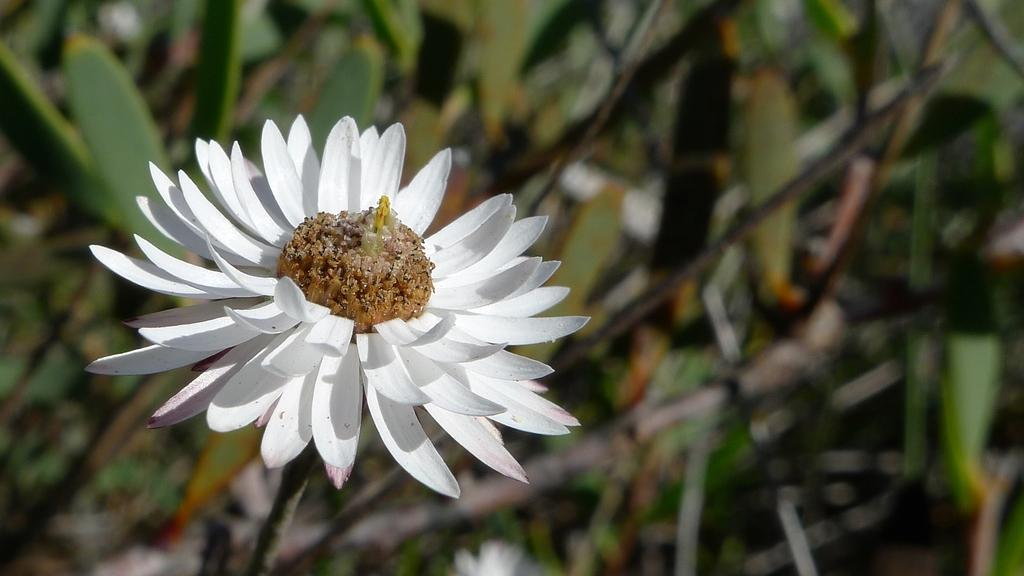What type of flower is in the picture? There is a white flower in the picture. Can you describe the background of the image? The background of the image is blurred. What type of stove is visible in the background of the image? There is no stove present in the image; it only features a white flower with a blurred background. 